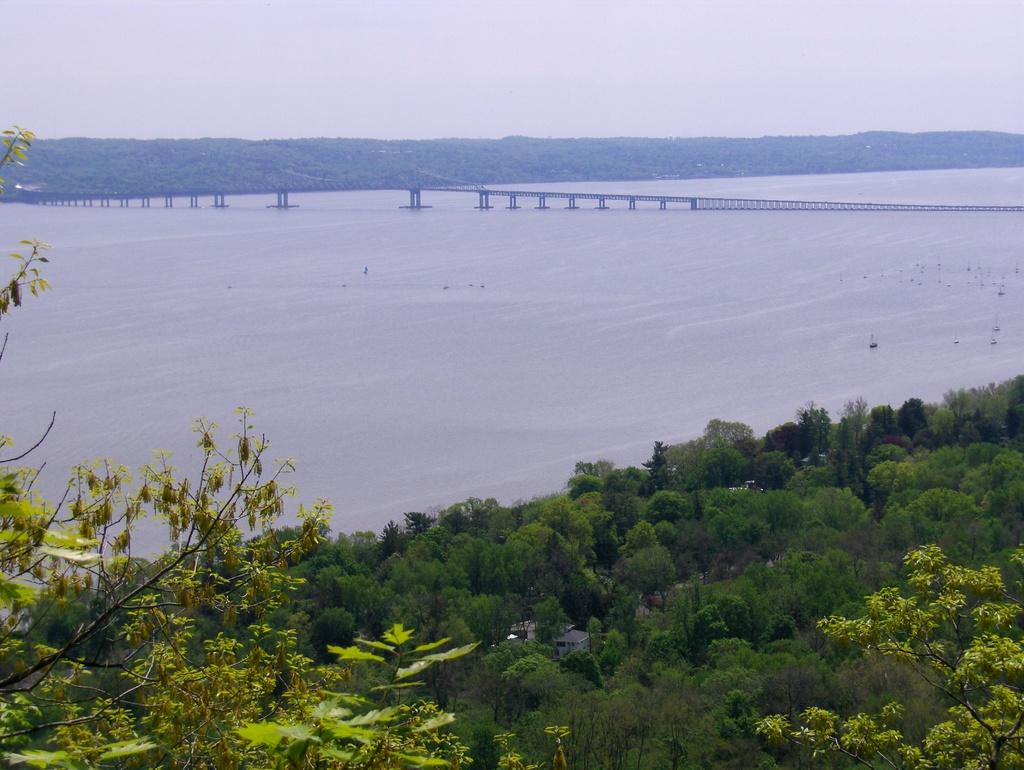What is the main feature of the landscape in the image? There is a river flowing in the image. What type of vegetation can be seen in the image? There are many trees in the image. Is there any man-made structure visible in the image? Yes, there is a bridge over the river in the image. What type of harmony is being played by the dogs in the image? There are no dogs or any indication of music in the image, so it is not possible to determine if any harmony is being played. 